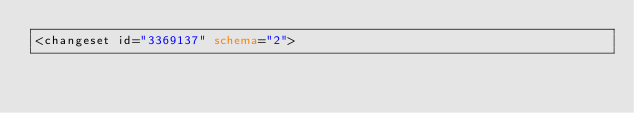Convert code to text. <code><loc_0><loc_0><loc_500><loc_500><_XML_><changeset id="3369137" schema="2"></code> 